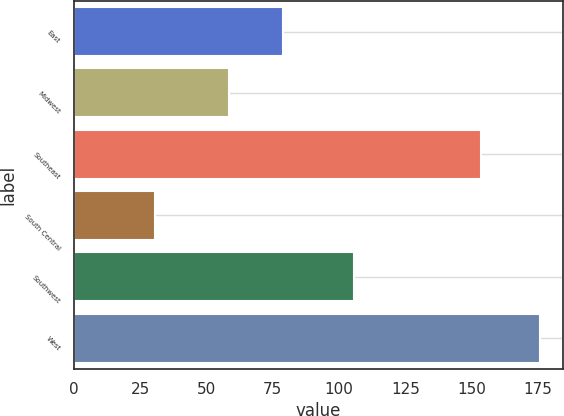Convert chart to OTSL. <chart><loc_0><loc_0><loc_500><loc_500><bar_chart><fcel>East<fcel>Midwest<fcel>Southeast<fcel>South Central<fcel>Southwest<fcel>West<nl><fcel>79<fcel>58.4<fcel>153.7<fcel>30.5<fcel>105.7<fcel>175.8<nl></chart> 